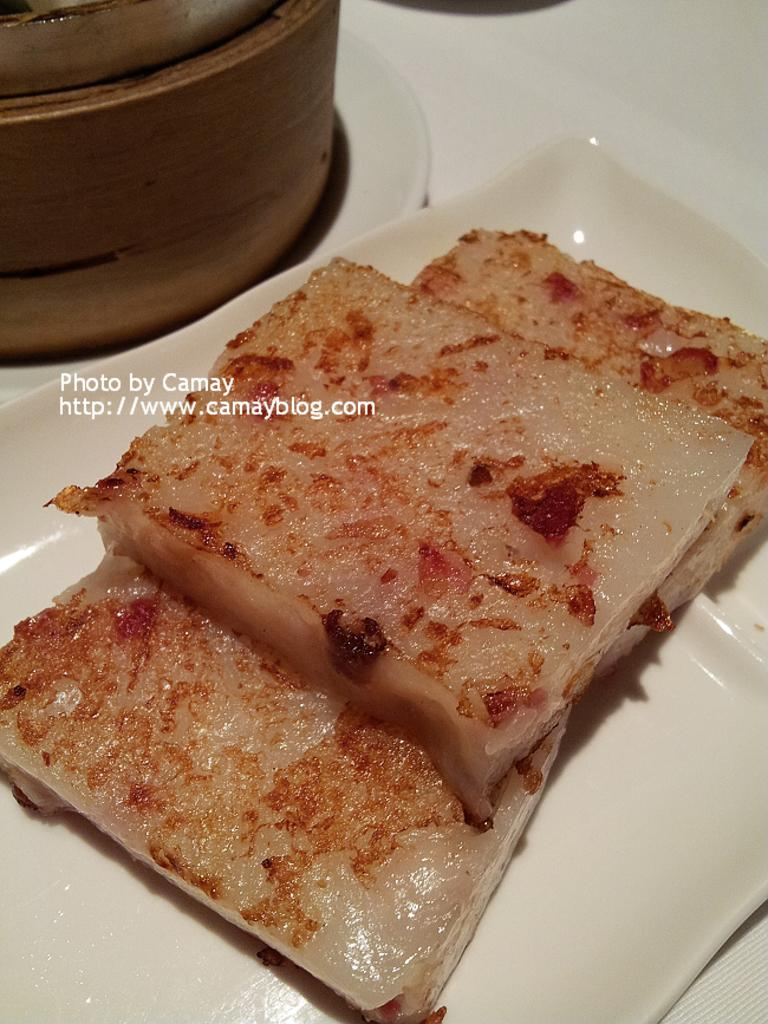What is present on the plate in the image? There are food items on the plate in the image. What else can be seen in the image besides the plate? There is a vessel in the image. Where might the plate, vessel, and food items be located? They are likely on a table, as suggested by the facts. In what type of setting is the image taken? The image is taken in a room. What type of riddle is written on the plate in the image? There is no riddle written on the plate in the image; it contains food items. How many bulbs are visible in the image? There are no bulbs present in the image. 